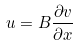<formula> <loc_0><loc_0><loc_500><loc_500>u = B \frac { \partial v } { \partial x }</formula> 